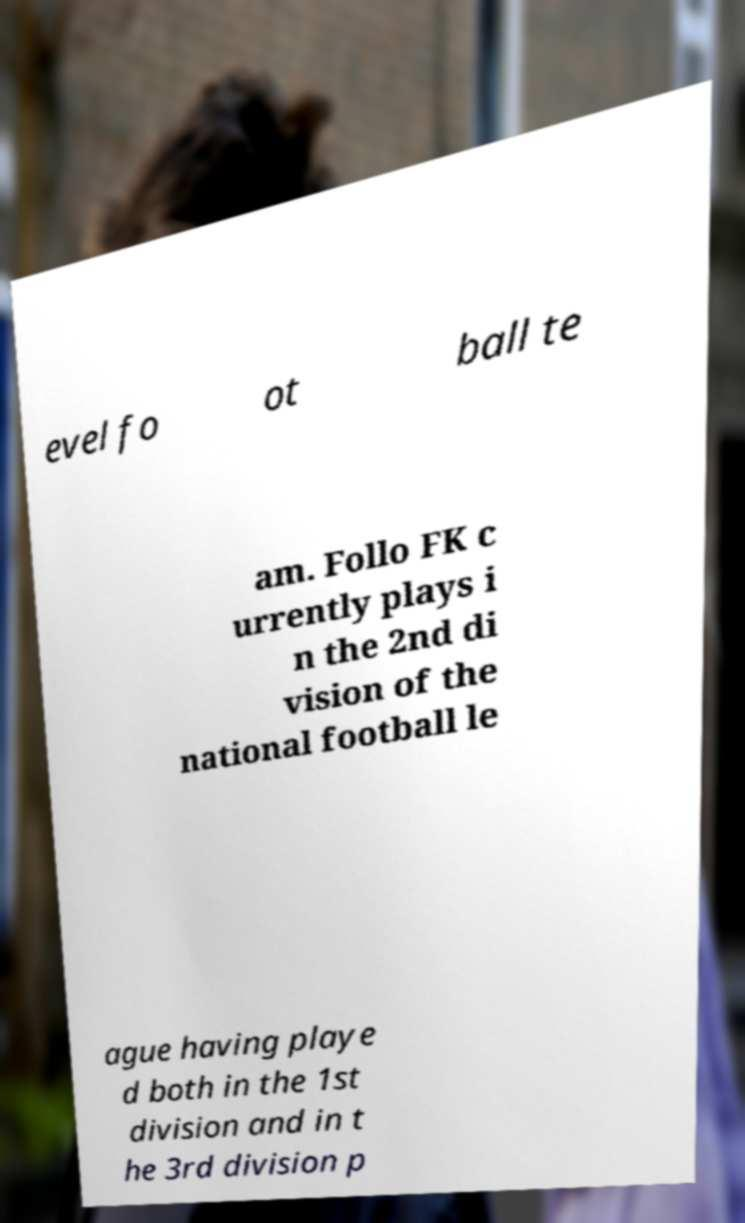There's text embedded in this image that I need extracted. Can you transcribe it verbatim? evel fo ot ball te am. Follo FK c urrently plays i n the 2nd di vision of the national football le ague having playe d both in the 1st division and in t he 3rd division p 